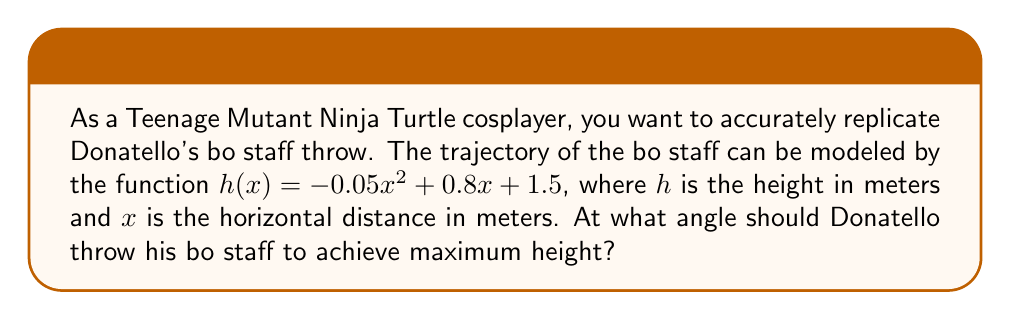Can you answer this question? To find the optimal angle for Donatello's bo staff throw, we need to determine the maximum height of the trajectory. This can be done by finding the vertex of the parabola described by the function $h(x)$.

Step 1: Identify the quadratic function
$h(x) = -0.05x^2 + 0.8x + 1.5$

Step 2: Find the x-coordinate of the vertex using the formula $x = -\frac{b}{2a}$
$a = -0.05$
$b = 0.8$
$x = -\frac{0.8}{2(-0.05)} = 8$ meters

Step 3: Calculate the maximum height by plugging x = 8 into the original function
$h(8) = -0.05(8)^2 + 0.8(8) + 1.5$
$= -0.05(64) + 6.4 + 1.5$
$= -3.2 + 6.4 + 1.5$
$= 4.7$ meters

Step 4: Calculate the angle of the throw using trigonometry
The angle can be found using the arctangent of the slope at x = 0:

$h'(x) = -0.1x + 0.8$
$h'(0) = 0.8$

$\theta = \arctan(0.8) \approx 38.66°$

Therefore, the optimal angle for Donatello to throw his bo staff is approximately 38.66° from the horizontal.
Answer: $38.66°$ 